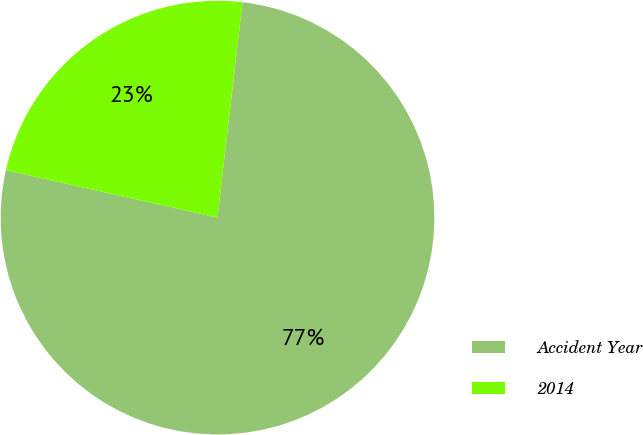Convert chart. <chart><loc_0><loc_0><loc_500><loc_500><pie_chart><fcel>Accident Year<fcel>2014<nl><fcel>76.67%<fcel>23.33%<nl></chart> 